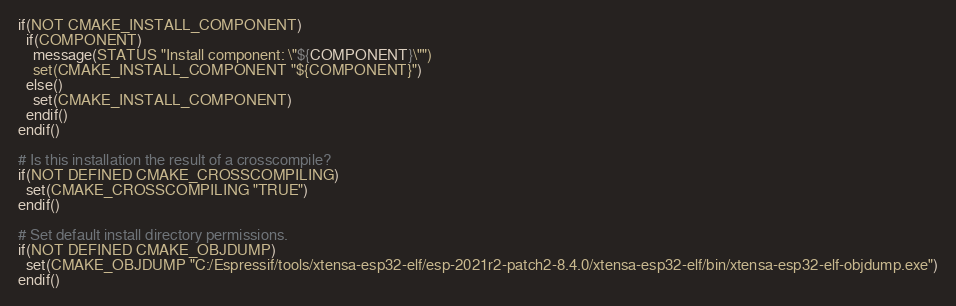Convert code to text. <code><loc_0><loc_0><loc_500><loc_500><_CMake_>if(NOT CMAKE_INSTALL_COMPONENT)
  if(COMPONENT)
    message(STATUS "Install component: \"${COMPONENT}\"")
    set(CMAKE_INSTALL_COMPONENT "${COMPONENT}")
  else()
    set(CMAKE_INSTALL_COMPONENT)
  endif()
endif()

# Is this installation the result of a crosscompile?
if(NOT DEFINED CMAKE_CROSSCOMPILING)
  set(CMAKE_CROSSCOMPILING "TRUE")
endif()

# Set default install directory permissions.
if(NOT DEFINED CMAKE_OBJDUMP)
  set(CMAKE_OBJDUMP "C:/Espressif/tools/xtensa-esp32-elf/esp-2021r2-patch2-8.4.0/xtensa-esp32-elf/bin/xtensa-esp32-elf-objdump.exe")
endif()

</code> 